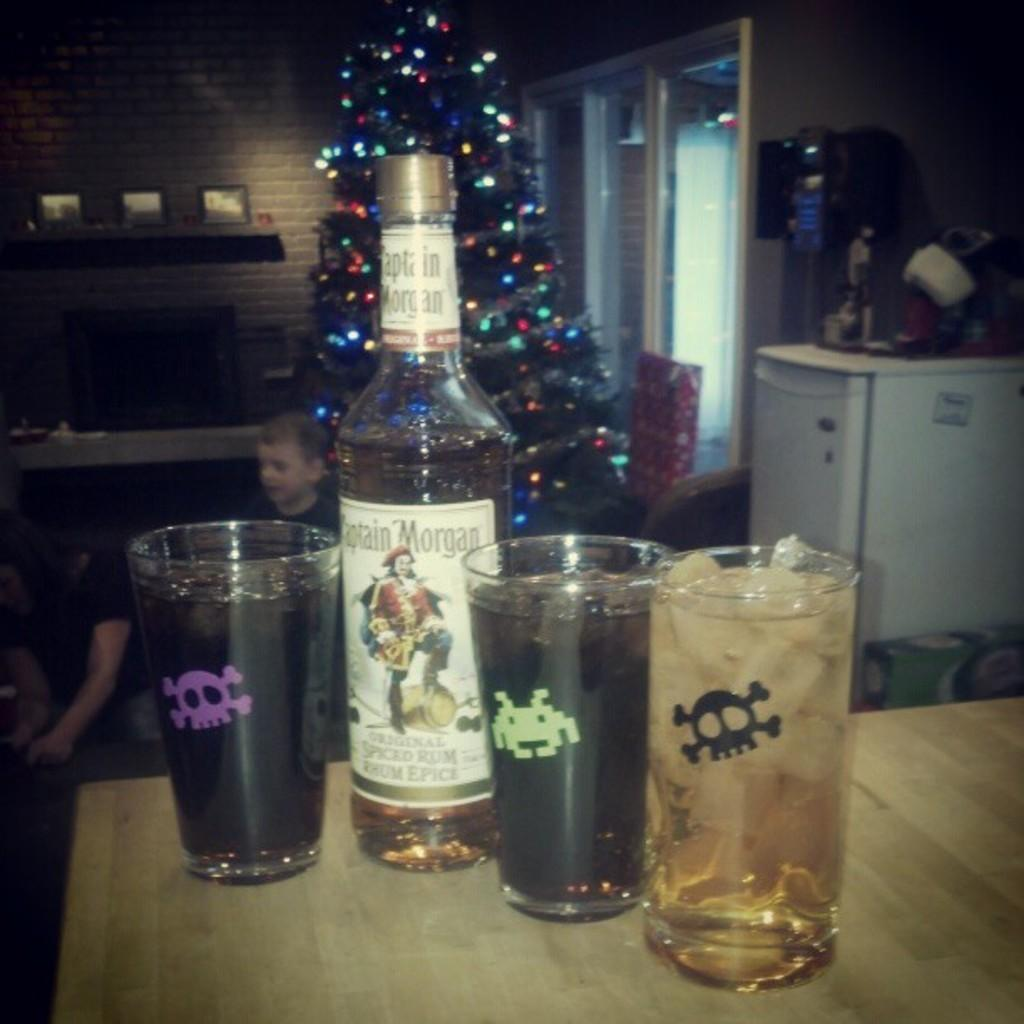<image>
Relay a brief, clear account of the picture shown. A bottle of Captain Morgan Spiced Rum is surrounded by three full glasses. 